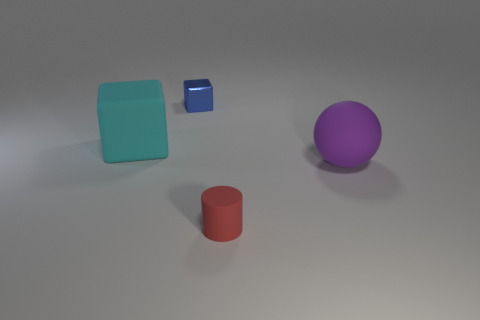Is the size of the object in front of the ball the same as the large cyan rubber thing?
Offer a terse response. No. How many objects are tiny gray matte objects or rubber balls?
Provide a short and direct response. 1. There is a object that is right of the large cyan cube and behind the big purple matte sphere; how big is it?
Offer a very short reply. Small. What number of tiny green balls are there?
Ensure brevity in your answer.  0. How many balls are small green things or large cyan objects?
Give a very brief answer. 0. What number of large rubber objects are in front of the big object that is to the left of the purple matte ball that is right of the big matte cube?
Provide a succinct answer. 1. The matte object that is the same size as the shiny thing is what color?
Give a very brief answer. Red. What number of other things are there of the same color as the small cylinder?
Give a very brief answer. 0. Are there more rubber things behind the small blue object than cyan matte balls?
Provide a succinct answer. No. Is the cyan thing made of the same material as the purple ball?
Ensure brevity in your answer.  Yes. 